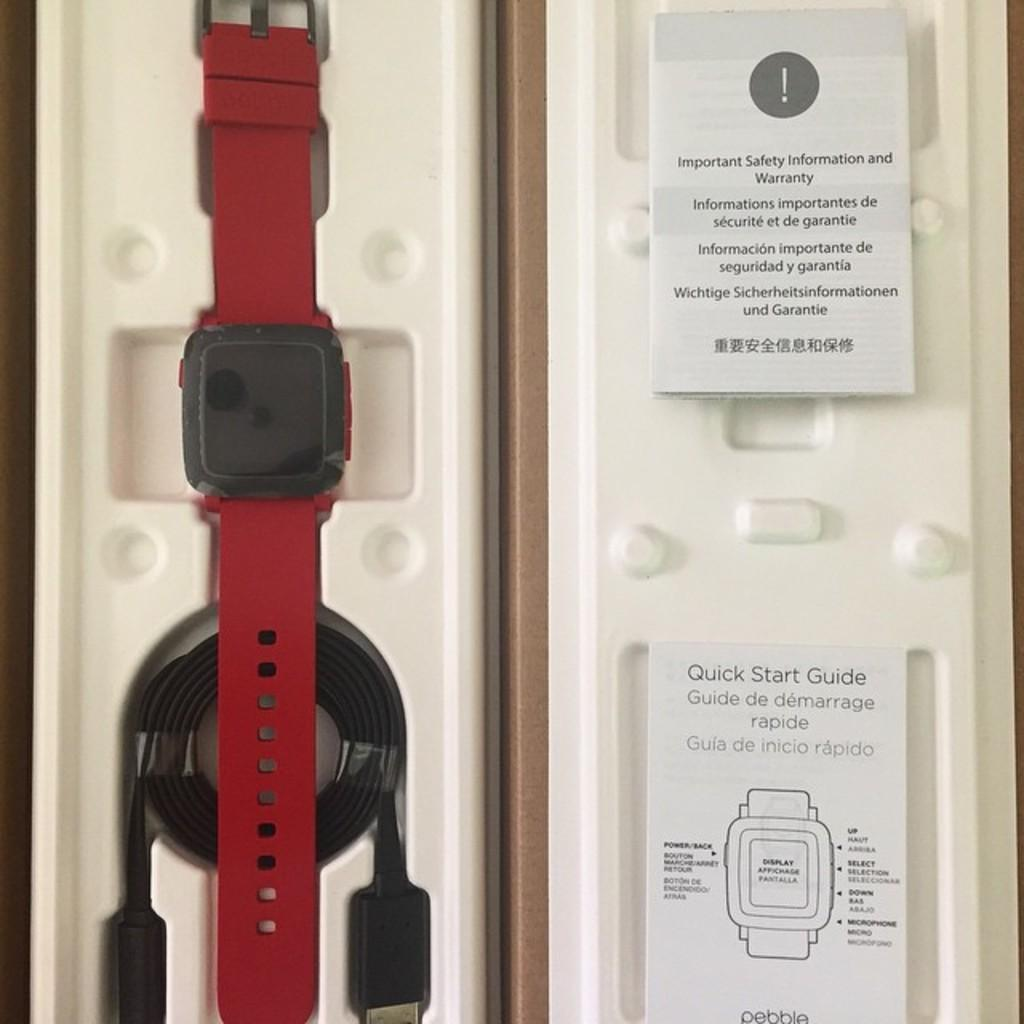<image>
Create a compact narrative representing the image presented. The new red watch has the instructions and a USB cable for charging. 